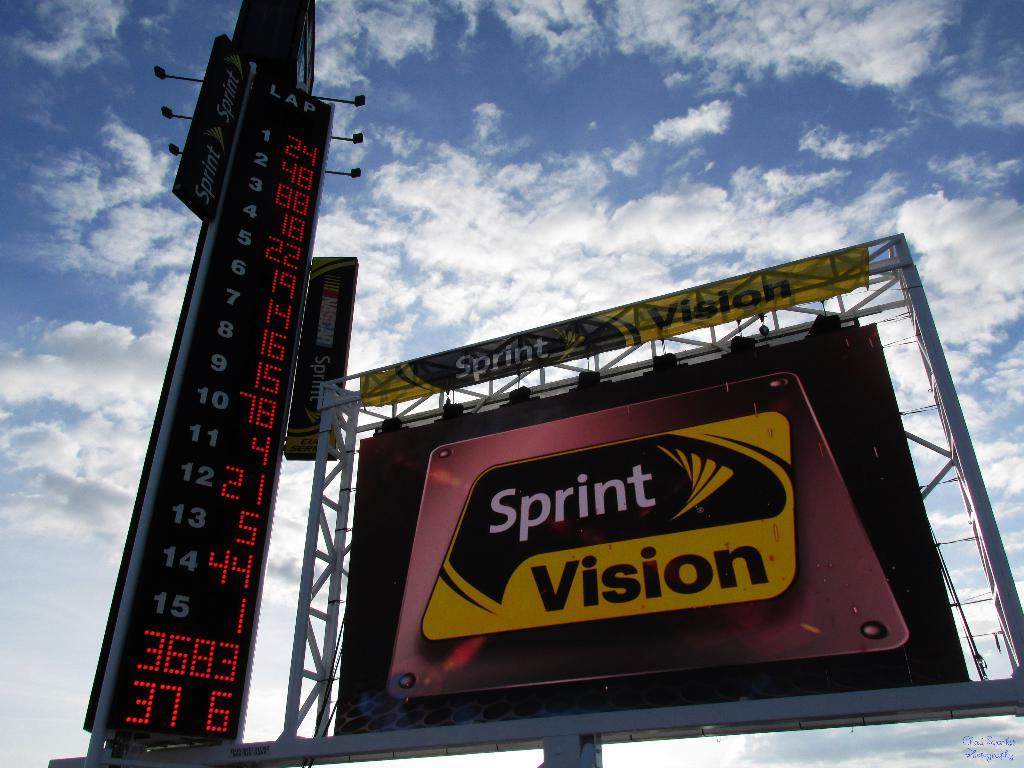<image>
Relay a brief, clear account of the picture shown. A billboard advertising Sprint Vision next to a digital sign. 